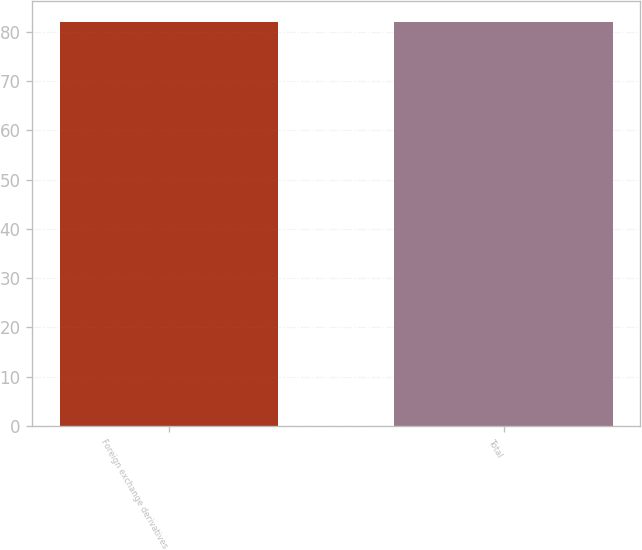Convert chart. <chart><loc_0><loc_0><loc_500><loc_500><bar_chart><fcel>Foreign exchange derivatives<fcel>Total<nl><fcel>82<fcel>82.1<nl></chart> 